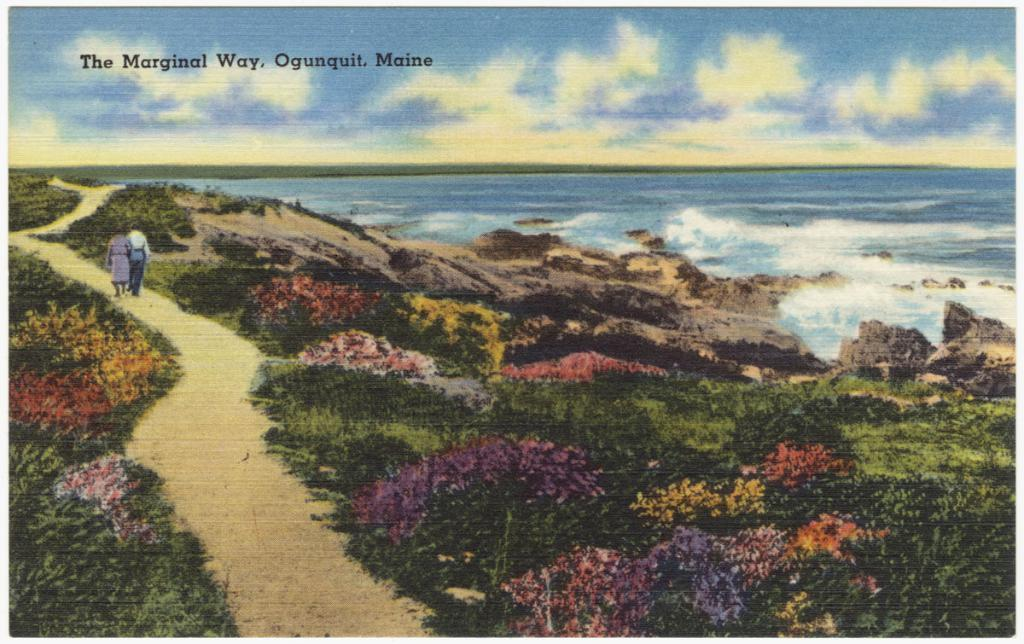What is the main subject in the image? There is a poster in the image. What part of the poster is draining water in the image? There is no part of the poster draining water in the image, as the provided facts do not mention any water or draining. 